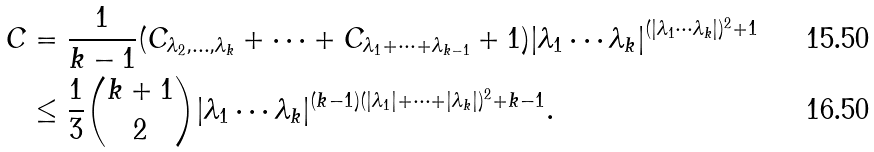Convert formula to latex. <formula><loc_0><loc_0><loc_500><loc_500>C & = \frac { 1 } { k - 1 } ( C _ { \lambda _ { 2 } , \dots , \lambda _ { k } } + \dots + C _ { \lambda _ { 1 } + \dots + \lambda _ { k - 1 } } + 1 ) | \lambda _ { 1 } \cdots \lambda _ { k } | ^ { ( | \lambda _ { 1 } \cdots \lambda _ { k } | ) ^ { 2 } + 1 } \\ & \leq \frac { 1 } { 3 } { k + 1 \choose 2 } | \lambda _ { 1 } \cdots \lambda _ { k } | ^ { ( k - 1 ) ( | \lambda _ { 1 } | + \dots + | \lambda _ { k } | ) ^ { 2 } + k - 1 } .</formula> 